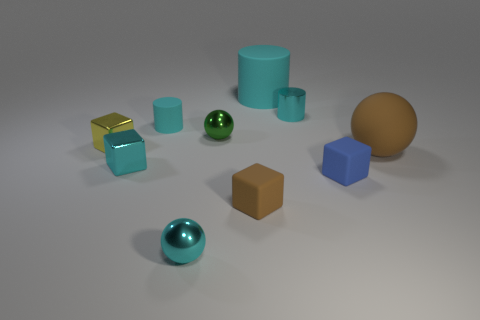Is there a large brown shiny object of the same shape as the green metal object?
Make the answer very short. No. How many red things are small shiny cylinders or big balls?
Your answer should be very brief. 0. Are there any gray metal balls of the same size as the green ball?
Make the answer very short. No. What number of small gray metallic cylinders are there?
Ensure brevity in your answer.  0. How many small objects are blue rubber objects or brown objects?
Provide a succinct answer. 2. What color is the tiny metallic sphere in front of the brown matte object right of the small cube that is right of the small metal cylinder?
Your answer should be very brief. Cyan. How many other things are the same color as the tiny rubber cylinder?
Your response must be concise. 4. How many rubber objects are either small spheres or gray spheres?
Keep it short and to the point. 0. Is the color of the rubber block to the left of the small cyan metal cylinder the same as the sphere right of the large cyan thing?
Your answer should be compact. Yes. What is the size of the brown object that is the same shape as the green object?
Offer a terse response. Large. 